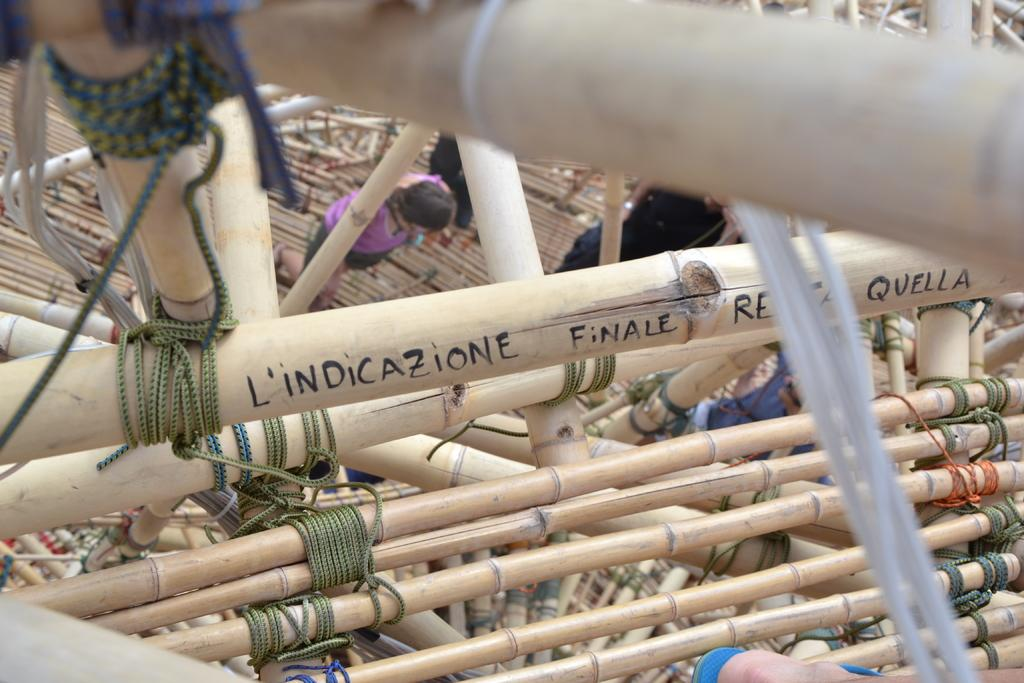What is the main object in the image? There are sticks tied together in the image. Is there any text or writing on the sticks? Yes, there is writing on the sticks. What can be seen in the background of the image? There are people walking in the background of the image. What type of mint is growing near the people walking in the image? There is no mint visible in the image; it only features sticks tied together with writing on them and people walking in the background. 